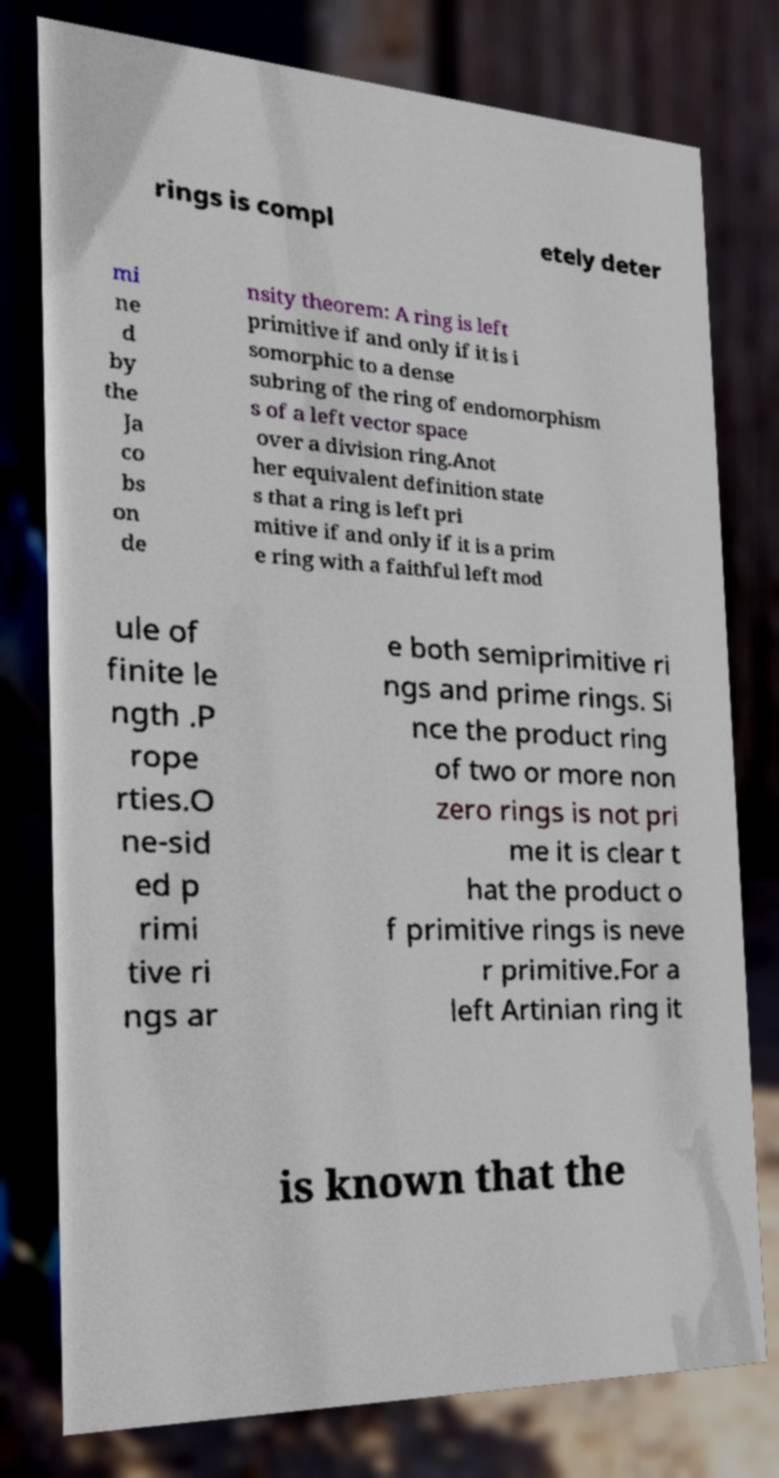Could you assist in decoding the text presented in this image and type it out clearly? rings is compl etely deter mi ne d by the Ja co bs on de nsity theorem: A ring is left primitive if and only if it is i somorphic to a dense subring of the ring of endomorphism s of a left vector space over a division ring.Anot her equivalent definition state s that a ring is left pri mitive if and only if it is a prim e ring with a faithful left mod ule of finite le ngth .P rope rties.O ne-sid ed p rimi tive ri ngs ar e both semiprimitive ri ngs and prime rings. Si nce the product ring of two or more non zero rings is not pri me it is clear t hat the product o f primitive rings is neve r primitive.For a left Artinian ring it is known that the 